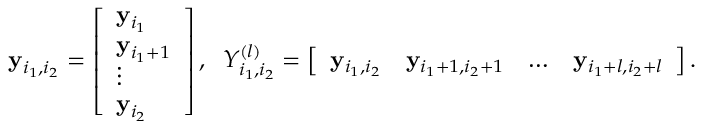Convert formula to latex. <formula><loc_0><loc_0><loc_500><loc_500>\begin{array} { r } { y _ { i _ { 1 } , i _ { 2 } } = \left [ \begin{array} { l } { y _ { i _ { 1 } } } \\ { y _ { i _ { 1 } + 1 } } \\ { \vdots } \\ { y _ { i _ { 2 } } } \end{array} \right ] , \, Y _ { i _ { 1 } , i _ { 2 } } ^ { ( l ) } = \left [ \begin{array} { l l l l } { y _ { i _ { 1 } , i _ { 2 } } } & { y _ { i _ { 1 } + 1 , i _ { 2 } + 1 } } & { \dots } & { y _ { i _ { 1 } + l , i _ { 2 } + l } } \end{array} \right ] . } \end{array}</formula> 